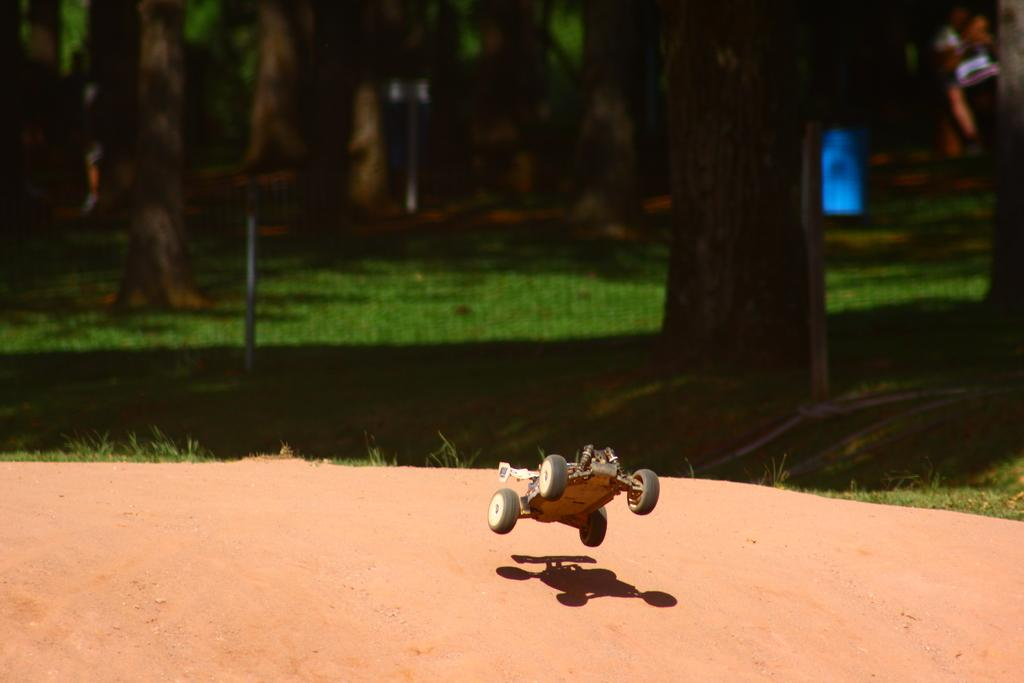What is the main subject in the center of the image? There is a toy in the center of the image. What can be seen in the background of the image? There is a mesh and trees visible in the background of the image. What type of vegetation is present in the background? Grass is visible in the background of the image. What is at the bottom of the image? The ground is at the bottom of the image. How many pies are being served on the back of the toy in the image? There are no pies present in the image, and the toy does not have a back. 